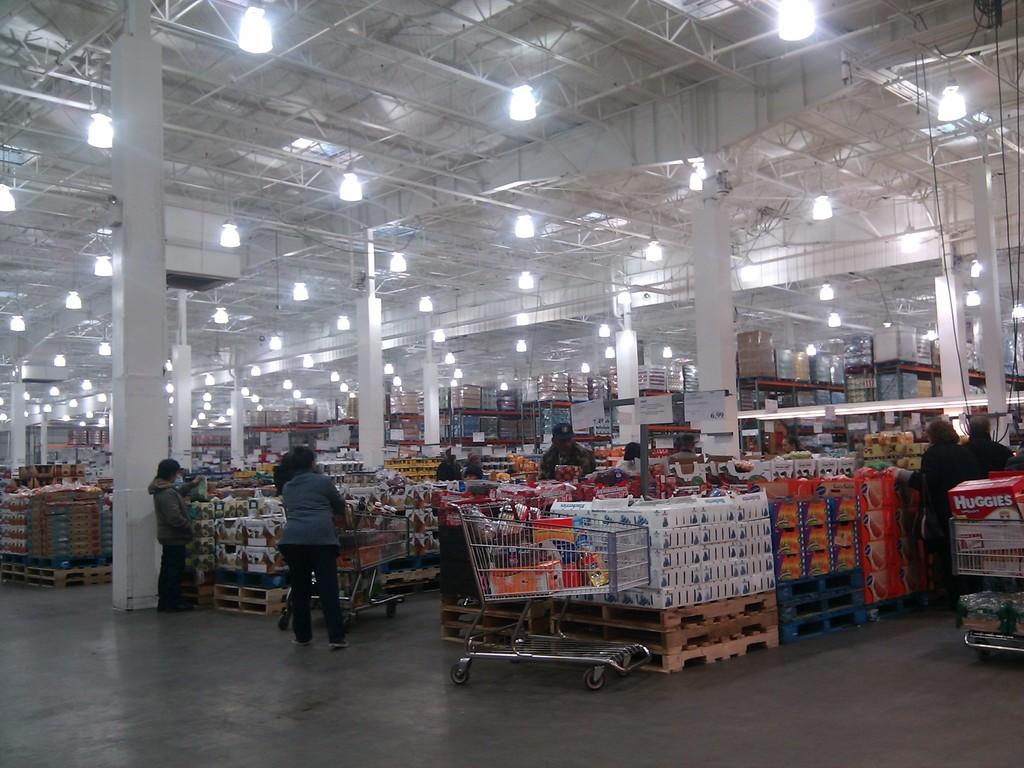<image>
Describe the image concisely. the large store has a customer with a box of huggies in it 